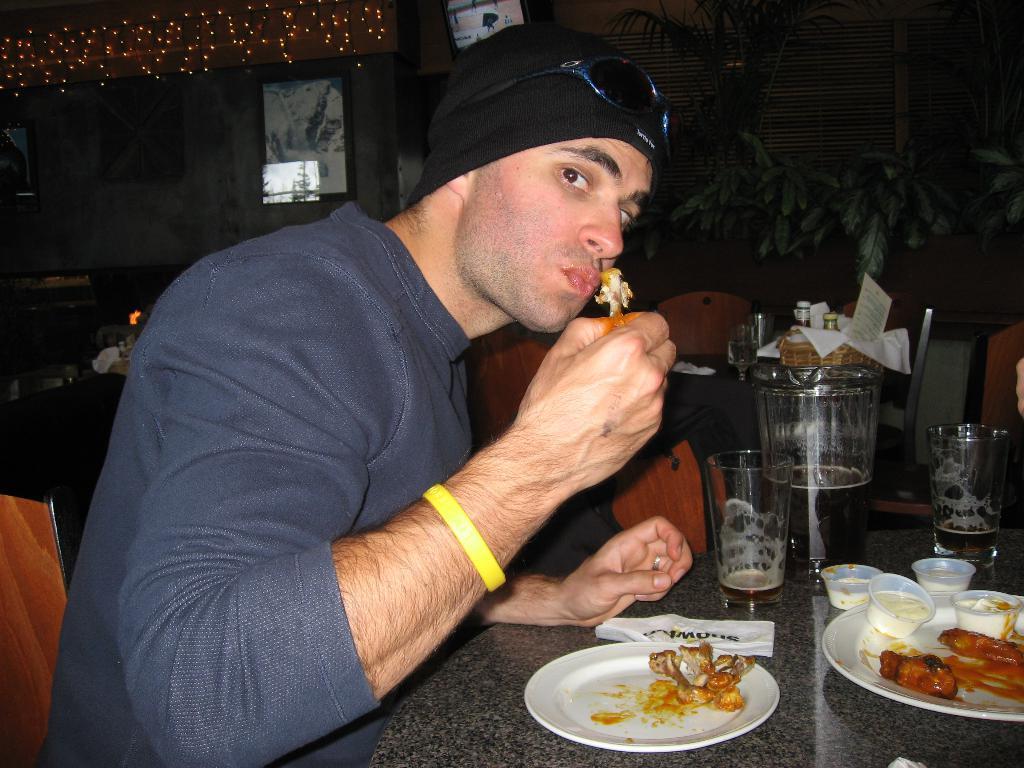In one or two sentences, can you explain what this image depicts? This image is taken indoors. In this image the background is a little dark. There are a few plants. There are a few window blinds. There is a mirror on the wall. There are a few rope lights and there are a few objects. There are a few empty chairs. There is a table with a few things on it. On the left side of the image a man is sitting on the chair and holding a food item in his hand. At the bottom of the image there is a table with two plates of food items, a few cups, two glasses and a few things on it. On the right side of the image there is a person and there is a chair. 